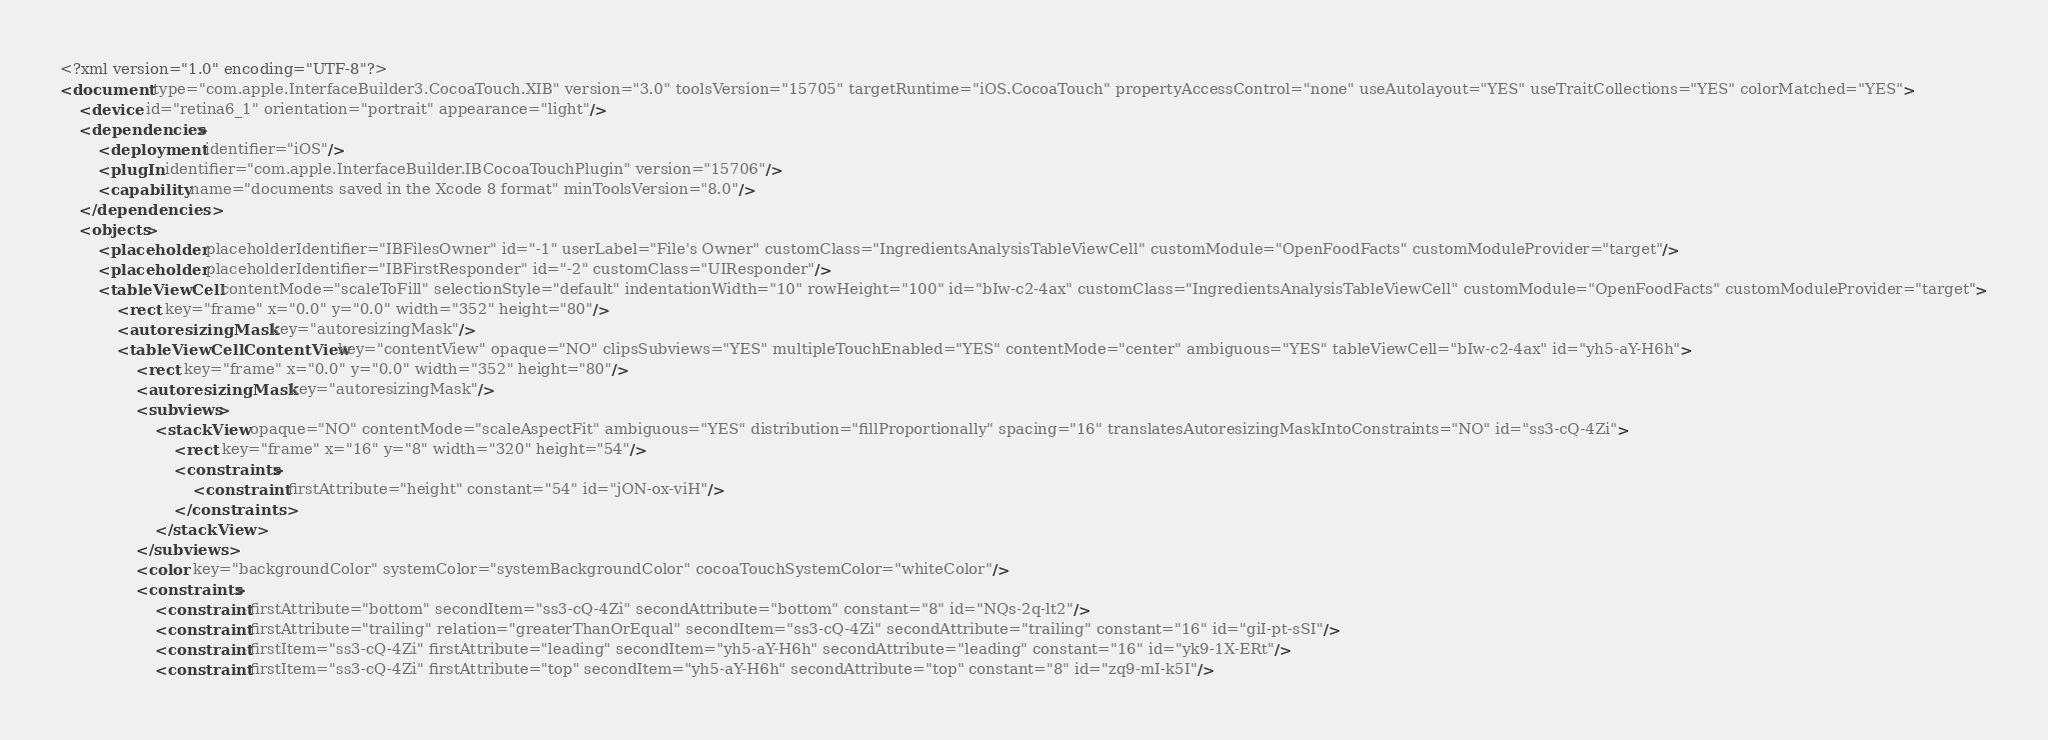<code> <loc_0><loc_0><loc_500><loc_500><_XML_><?xml version="1.0" encoding="UTF-8"?>
<document type="com.apple.InterfaceBuilder3.CocoaTouch.XIB" version="3.0" toolsVersion="15705" targetRuntime="iOS.CocoaTouch" propertyAccessControl="none" useAutolayout="YES" useTraitCollections="YES" colorMatched="YES">
    <device id="retina6_1" orientation="portrait" appearance="light"/>
    <dependencies>
        <deployment identifier="iOS"/>
        <plugIn identifier="com.apple.InterfaceBuilder.IBCocoaTouchPlugin" version="15706"/>
        <capability name="documents saved in the Xcode 8 format" minToolsVersion="8.0"/>
    </dependencies>
    <objects>
        <placeholder placeholderIdentifier="IBFilesOwner" id="-1" userLabel="File's Owner" customClass="IngredientsAnalysisTableViewCell" customModule="OpenFoodFacts" customModuleProvider="target"/>
        <placeholder placeholderIdentifier="IBFirstResponder" id="-2" customClass="UIResponder"/>
        <tableViewCell contentMode="scaleToFill" selectionStyle="default" indentationWidth="10" rowHeight="100" id="bIw-c2-4ax" customClass="IngredientsAnalysisTableViewCell" customModule="OpenFoodFacts" customModuleProvider="target">
            <rect key="frame" x="0.0" y="0.0" width="352" height="80"/>
            <autoresizingMask key="autoresizingMask"/>
            <tableViewCellContentView key="contentView" opaque="NO" clipsSubviews="YES" multipleTouchEnabled="YES" contentMode="center" ambiguous="YES" tableViewCell="bIw-c2-4ax" id="yh5-aY-H6h">
                <rect key="frame" x="0.0" y="0.0" width="352" height="80"/>
                <autoresizingMask key="autoresizingMask"/>
                <subviews>
                    <stackView opaque="NO" contentMode="scaleAspectFit" ambiguous="YES" distribution="fillProportionally" spacing="16" translatesAutoresizingMaskIntoConstraints="NO" id="ss3-cQ-4Zi">
                        <rect key="frame" x="16" y="8" width="320" height="54"/>
                        <constraints>
                            <constraint firstAttribute="height" constant="54" id="jON-ox-viH"/>
                        </constraints>
                    </stackView>
                </subviews>
                <color key="backgroundColor" systemColor="systemBackgroundColor" cocoaTouchSystemColor="whiteColor"/>
                <constraints>
                    <constraint firstAttribute="bottom" secondItem="ss3-cQ-4Zi" secondAttribute="bottom" constant="8" id="NQs-2q-lt2"/>
                    <constraint firstAttribute="trailing" relation="greaterThanOrEqual" secondItem="ss3-cQ-4Zi" secondAttribute="trailing" constant="16" id="giI-pt-sSI"/>
                    <constraint firstItem="ss3-cQ-4Zi" firstAttribute="leading" secondItem="yh5-aY-H6h" secondAttribute="leading" constant="16" id="yk9-1X-ERt"/>
                    <constraint firstItem="ss3-cQ-4Zi" firstAttribute="top" secondItem="yh5-aY-H6h" secondAttribute="top" constant="8" id="zq9-mI-k5I"/></code> 